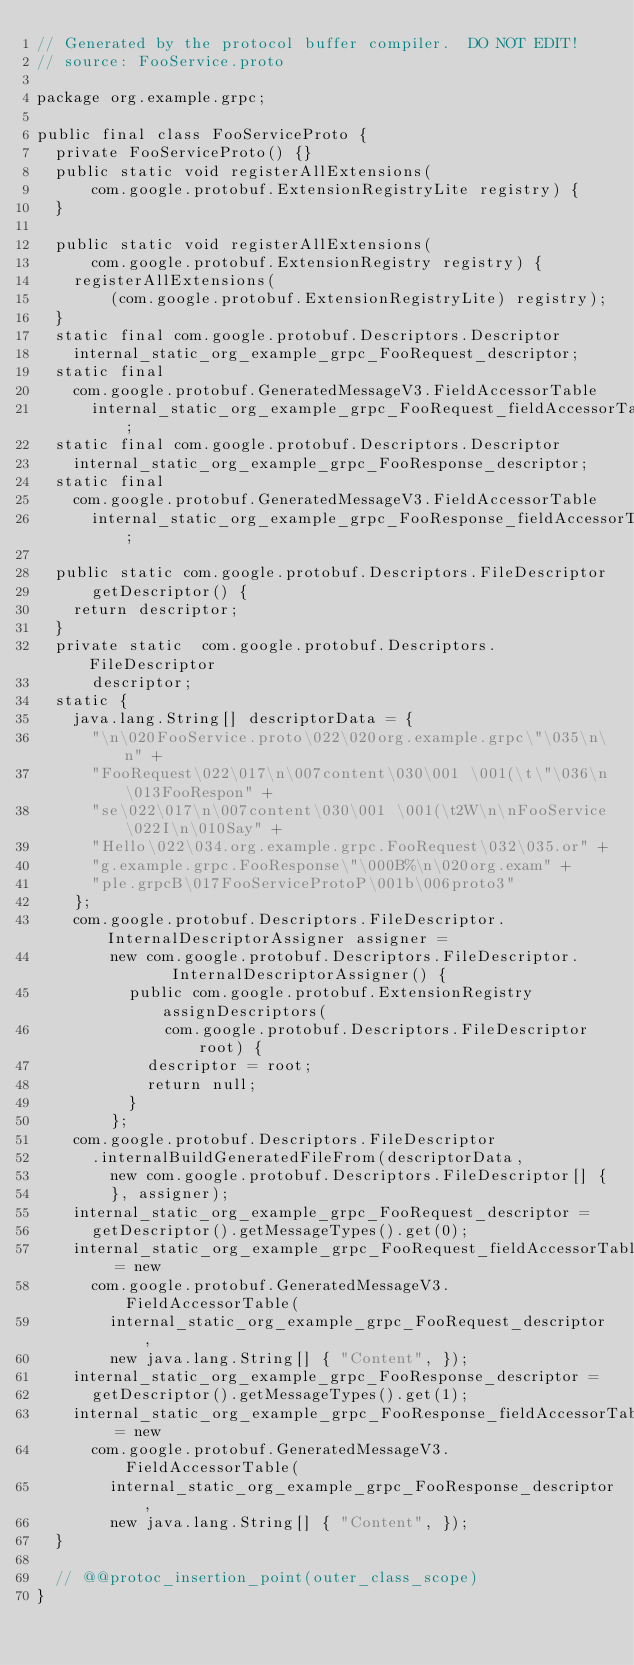Convert code to text. <code><loc_0><loc_0><loc_500><loc_500><_Java_>// Generated by the protocol buffer compiler.  DO NOT EDIT!
// source: FooService.proto

package org.example.grpc;

public final class FooServiceProto {
  private FooServiceProto() {}
  public static void registerAllExtensions(
      com.google.protobuf.ExtensionRegistryLite registry) {
  }

  public static void registerAllExtensions(
      com.google.protobuf.ExtensionRegistry registry) {
    registerAllExtensions(
        (com.google.protobuf.ExtensionRegistryLite) registry);
  }
  static final com.google.protobuf.Descriptors.Descriptor
    internal_static_org_example_grpc_FooRequest_descriptor;
  static final 
    com.google.protobuf.GeneratedMessageV3.FieldAccessorTable
      internal_static_org_example_grpc_FooRequest_fieldAccessorTable;
  static final com.google.protobuf.Descriptors.Descriptor
    internal_static_org_example_grpc_FooResponse_descriptor;
  static final 
    com.google.protobuf.GeneratedMessageV3.FieldAccessorTable
      internal_static_org_example_grpc_FooResponse_fieldAccessorTable;

  public static com.google.protobuf.Descriptors.FileDescriptor
      getDescriptor() {
    return descriptor;
  }
  private static  com.google.protobuf.Descriptors.FileDescriptor
      descriptor;
  static {
    java.lang.String[] descriptorData = {
      "\n\020FooService.proto\022\020org.example.grpc\"\035\n\n" +
      "FooRequest\022\017\n\007content\030\001 \001(\t\"\036\n\013FooRespon" +
      "se\022\017\n\007content\030\001 \001(\t2W\n\nFooService\022I\n\010Say" +
      "Hello\022\034.org.example.grpc.FooRequest\032\035.or" +
      "g.example.grpc.FooResponse\"\000B%\n\020org.exam" +
      "ple.grpcB\017FooServiceProtoP\001b\006proto3"
    };
    com.google.protobuf.Descriptors.FileDescriptor.InternalDescriptorAssigner assigner =
        new com.google.protobuf.Descriptors.FileDescriptor.    InternalDescriptorAssigner() {
          public com.google.protobuf.ExtensionRegistry assignDescriptors(
              com.google.protobuf.Descriptors.FileDescriptor root) {
            descriptor = root;
            return null;
          }
        };
    com.google.protobuf.Descriptors.FileDescriptor
      .internalBuildGeneratedFileFrom(descriptorData,
        new com.google.protobuf.Descriptors.FileDescriptor[] {
        }, assigner);
    internal_static_org_example_grpc_FooRequest_descriptor =
      getDescriptor().getMessageTypes().get(0);
    internal_static_org_example_grpc_FooRequest_fieldAccessorTable = new
      com.google.protobuf.GeneratedMessageV3.FieldAccessorTable(
        internal_static_org_example_grpc_FooRequest_descriptor,
        new java.lang.String[] { "Content", });
    internal_static_org_example_grpc_FooResponse_descriptor =
      getDescriptor().getMessageTypes().get(1);
    internal_static_org_example_grpc_FooResponse_fieldAccessorTable = new
      com.google.protobuf.GeneratedMessageV3.FieldAccessorTable(
        internal_static_org_example_grpc_FooResponse_descriptor,
        new java.lang.String[] { "Content", });
  }

  // @@protoc_insertion_point(outer_class_scope)
}
</code> 